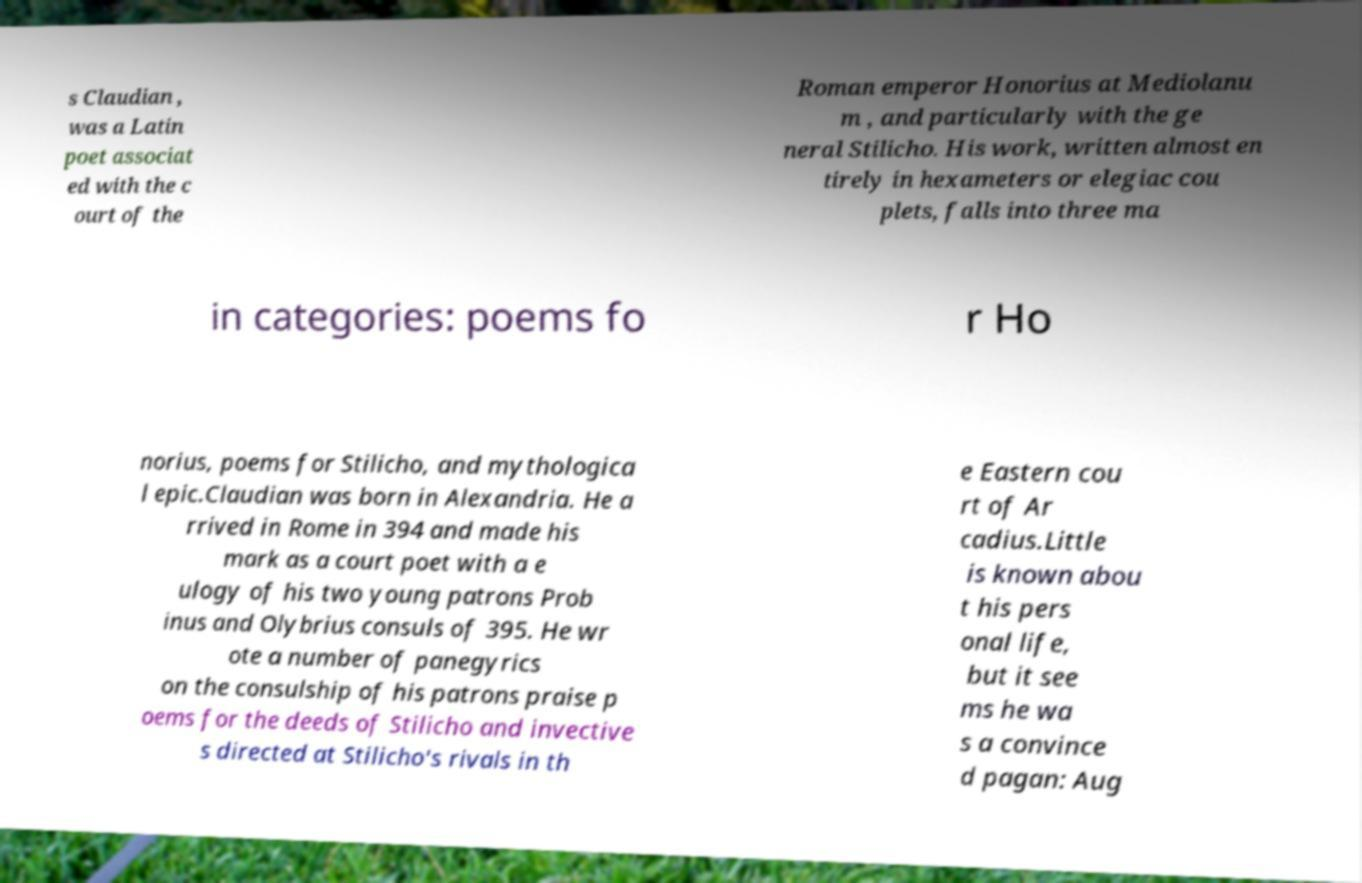Could you extract and type out the text from this image? s Claudian , was a Latin poet associat ed with the c ourt of the Roman emperor Honorius at Mediolanu m , and particularly with the ge neral Stilicho. His work, written almost en tirely in hexameters or elegiac cou plets, falls into three ma in categories: poems fo r Ho norius, poems for Stilicho, and mythologica l epic.Claudian was born in Alexandria. He a rrived in Rome in 394 and made his mark as a court poet with a e ulogy of his two young patrons Prob inus and Olybrius consuls of 395. He wr ote a number of panegyrics on the consulship of his patrons praise p oems for the deeds of Stilicho and invective s directed at Stilicho's rivals in th e Eastern cou rt of Ar cadius.Little is known abou t his pers onal life, but it see ms he wa s a convince d pagan: Aug 